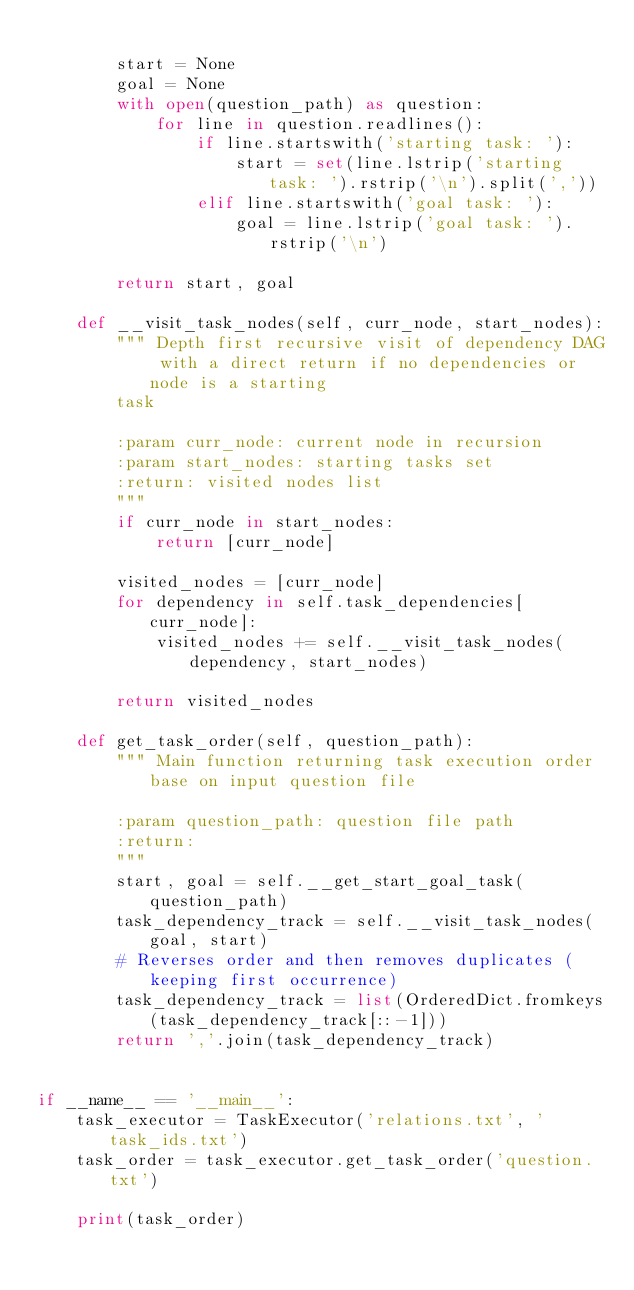<code> <loc_0><loc_0><loc_500><loc_500><_Python_>
        start = None
        goal = None
        with open(question_path) as question:
            for line in question.readlines():
                if line.startswith('starting task: '):
                    start = set(line.lstrip('starting task: ').rstrip('\n').split(','))
                elif line.startswith('goal task: '):
                    goal = line.lstrip('goal task: ').rstrip('\n')

        return start, goal

    def __visit_task_nodes(self, curr_node, start_nodes):
        """ Depth first recursive visit of dependency DAG with a direct return if no dependencies or node is a starting
        task

        :param curr_node: current node in recursion
        :param start_nodes: starting tasks set
        :return: visited nodes list
        """
        if curr_node in start_nodes:
            return [curr_node]

        visited_nodes = [curr_node]
        for dependency in self.task_dependencies[curr_node]:
            visited_nodes += self.__visit_task_nodes(dependency, start_nodes)

        return visited_nodes

    def get_task_order(self, question_path):
        """ Main function returning task execution order base on input question file

        :param question_path: question file path
        :return:
        """
        start, goal = self.__get_start_goal_task(question_path)
        task_dependency_track = self.__visit_task_nodes(goal, start)
        # Reverses order and then removes duplicates (keeping first occurrence)
        task_dependency_track = list(OrderedDict.fromkeys(task_dependency_track[::-1]))
        return ','.join(task_dependency_track)


if __name__ == '__main__':
    task_executor = TaskExecutor('relations.txt', 'task_ids.txt')
    task_order = task_executor.get_task_order('question.txt')

    print(task_order)
</code> 